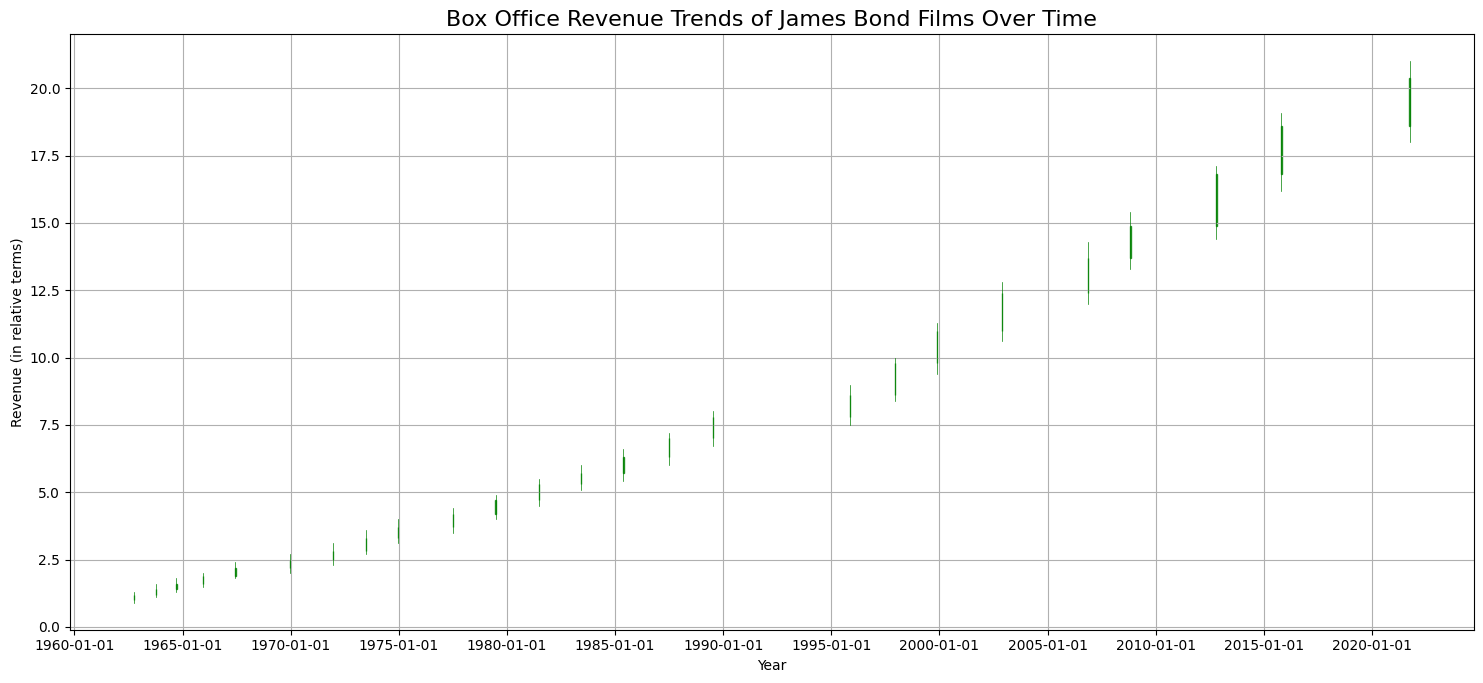What period shows the sharpest increase in box office revenue? Explain how you found this period. To determine the sharpest increase, we compare the differences between the closing prices of adjacent periods. The biggest jump is from the period 1999-11-19 (close at 11.0) to 2002-11-22 (close at 12.4), an increase of 1.4.
Answer: 1999-11-19 to 2002-11-22 Which year had the highest recorded box office revenue at closing? By examining the closing values across the entire timeline, the highest recorded closing value is 20.4 in the year 2021.
Answer: 2021 Compare the box office revenue trends between 1971 and 1977. What do you observe? Between 1971 and 1977, the closing values increase from 2.8 (1971-12-14) to 4.2 (1977-07-07). This indicates a steady and significant rise over this period.
Answer: Steady and significant rise Identify a period when the box office revenue did not change significantly. From 1987-06-29 (close at 7.0) to 1989-07-14 (close at 7.8), the revenue shows minor growth, indicating not a very significant change compared to other periods.
Answer: 1987-06-29 to 1989-07-14 Calculate the average box office revenue close value from 2008 to 2021. The closing values within this period are 14.9 (2008-10-29), 16.8 (2012-10-23), 18.6 (2015-10-26), and 20.4 (2021-09-30). Summing these gives 70.7, and dividing by 4 gives an average of about 17.675.
Answer: 17.675 Between which two consecutive periods was there a decrease in box office revenue? Comparing consecutive periods for drops, from 2015-10-26 (close at 18.6) to 2021-09-30 (close at 20.4), there is an increase; however, a notable decrease is not identified in these periods, showcasing steady growth overall.
Answer: No significant decrease How does the box office revenue trend between 1962 and 1971 compare to the trend from 1995 to 2002? Between 1962-10-05 and 1971-12-14, revenues rose from 1.2 to 2.8, which is a significant growth period. The period from 1995-11-13 to 2002-11-22 shows a rise from 8.6 to 12.4, indicating an even steeper growth pattern as the franchise gained higher popularity.
Answer: Higher growth from 1995 to 2002 